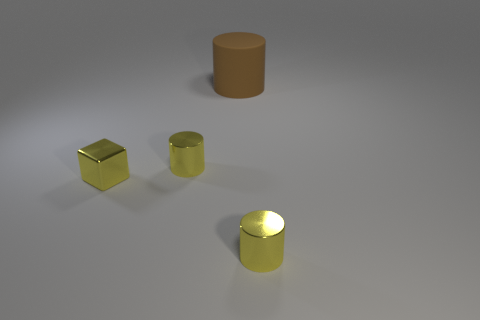How many metallic cylinders are behind the tiny yellow metallic cylinder right of the matte object?
Make the answer very short. 1. Is there a small yellow shiny cylinder?
Ensure brevity in your answer.  Yes. Are there any small things made of the same material as the large cylinder?
Your answer should be very brief. No. Is the number of large matte cylinders that are right of the big thing greater than the number of things on the right side of the small metal cube?
Provide a short and direct response. No. Does the brown object have the same size as the yellow cube?
Your answer should be very brief. No. What is the color of the shiny cylinder on the left side of the metallic thing that is in front of the yellow metallic cube?
Your response must be concise. Yellow. What is the color of the large cylinder?
Provide a short and direct response. Brown. Is there a metallic block of the same color as the big cylinder?
Give a very brief answer. No. Do the tiny cylinder left of the large matte object and the small cube have the same color?
Provide a succinct answer. Yes. How many things are yellow things that are behind the block or cubes?
Ensure brevity in your answer.  2. 